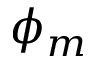<formula> <loc_0><loc_0><loc_500><loc_500>\phi _ { m }</formula> 